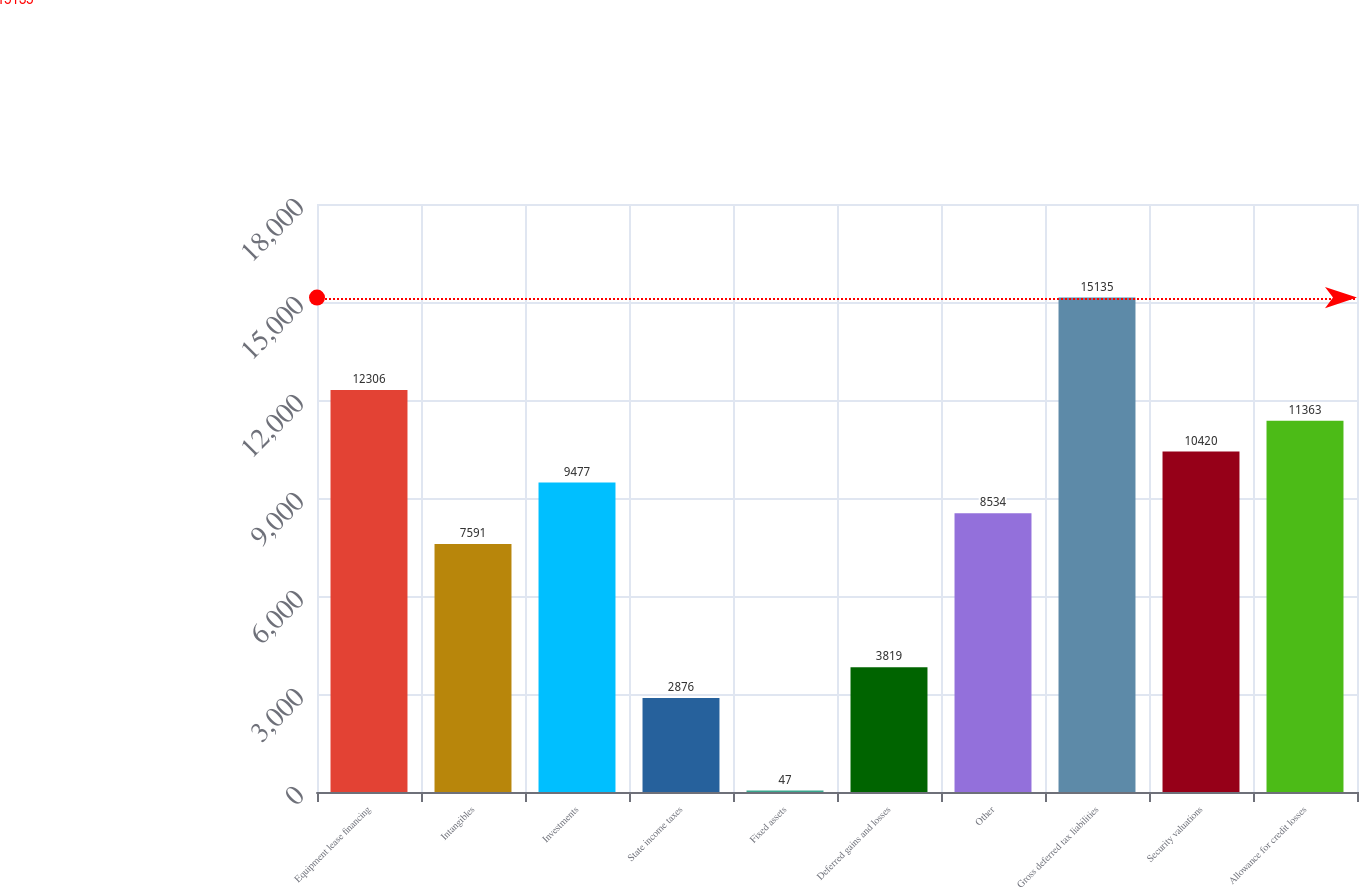Convert chart to OTSL. <chart><loc_0><loc_0><loc_500><loc_500><bar_chart><fcel>Equipment lease financing<fcel>Intangibles<fcel>Investments<fcel>State income taxes<fcel>Fixed assets<fcel>Deferred gains and losses<fcel>Other<fcel>Gross deferred tax liabilities<fcel>Security valuations<fcel>Allowance for credit losses<nl><fcel>12306<fcel>7591<fcel>9477<fcel>2876<fcel>47<fcel>3819<fcel>8534<fcel>15135<fcel>10420<fcel>11363<nl></chart> 